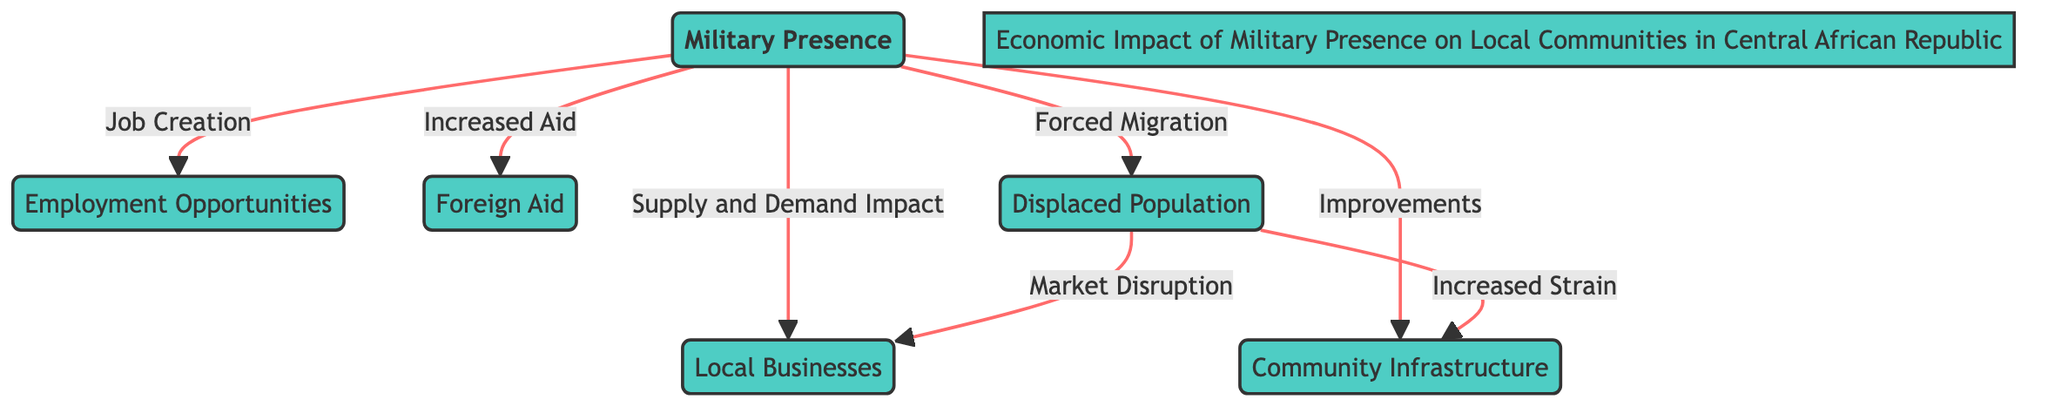What is the central theme of the diagram? The diagram's central theme is "Military Presence," indicated at the center of the flowchart. All other nodes relate to its impact on local communities in the Central African Republic.
Answer: Military Presence How many nodes are in the diagram? By counting each distinct element in the diagram, we find that there are six nodes: Military Presence, Local Businesses, Employment Opportunities, Foreign Aid, Community Infrastructure, and Displaced Population.
Answer: Six What impact does military presence have on local businesses? The diagram shows that military presence has a direct relationship with local businesses through a "Supply and Demand Impact."
Answer: Supply and Demand Impact What is the effect of displaced population on local businesses? The diagram indicates that displaced populations lead to "Market Disruption," which negatively affects local businesses.
Answer: Market Disruption What are the two impacts of displaced population on community infrastructure? The diagram illustrates that displaced populations result in "Increased Strain" and also connect to "Market Disruption," indirectly impacting community infrastructure.
Answer: Increased Strain and Market Disruption How does military presence affect employment opportunities? According to the diagram, military presence creates "Job Creation," which directly affects employment opportunities in local communities.
Answer: Job Creation What is one of the direct benefits of military presence concerning foreign aid? The diagram specifies that military presence leads to "Increased Aid," demonstrating a positive impact on foreign aid in local communities.
Answer: Increased Aid How does community infrastructure benefit from military presence? The diagram suggests that military presence results in "Improvements" in community infrastructure, showing a constructive effect.
Answer: Improvements Which node is connected to both local businesses and community infrastructure? The "Displaced Population" node has connections to both local businesses (through Market Disruption) and community infrastructure (through Increased Strain).
Answer: Displaced Population 